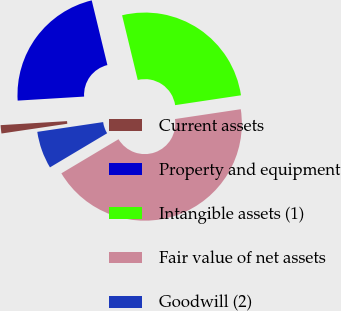Convert chart. <chart><loc_0><loc_0><loc_500><loc_500><pie_chart><fcel>Current assets<fcel>Property and equipment<fcel>Intangible assets (1)<fcel>Fair value of net assets<fcel>Goodwill (2)<nl><fcel>1.38%<fcel>22.18%<fcel>26.42%<fcel>43.8%<fcel>6.22%<nl></chart> 